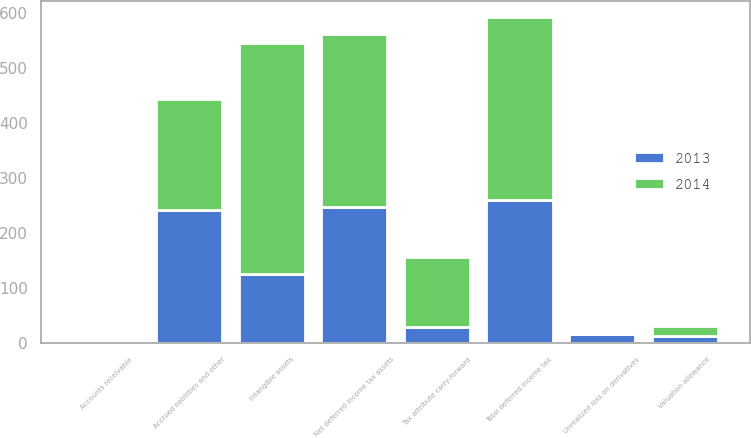<chart> <loc_0><loc_0><loc_500><loc_500><stacked_bar_chart><ecel><fcel>Accounts receivable<fcel>Tax attribute carry-forward<fcel>Unrealized loss on derivatives<fcel>Accrued liabilities and other<fcel>Total deferred income tax<fcel>Valuation allowance<fcel>Net deferred income tax assets<fcel>Intangible assets<nl><fcel>2013<fcel>3<fcel>30<fcel>16<fcel>243<fcel>260<fcel>13<fcel>247<fcel>126<nl><fcel>2014<fcel>3<fcel>126<fcel>2<fcel>202<fcel>333<fcel>18<fcel>315<fcel>421<nl></chart> 